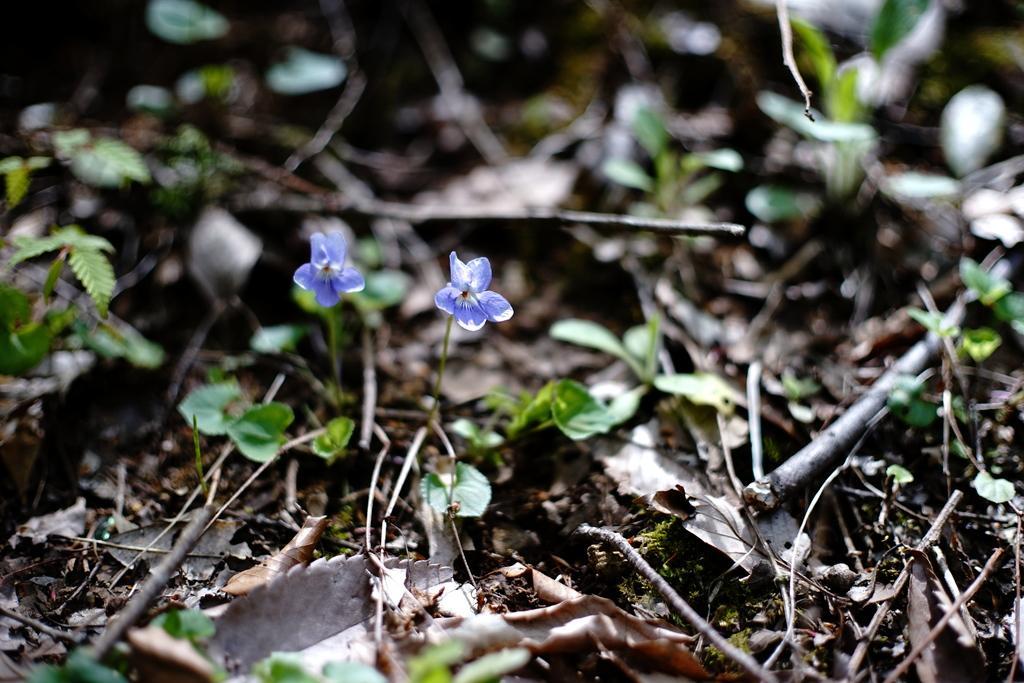Please provide a concise description of this image. In this picture we can see some plants and leaves, there are two flowers in the middle. 